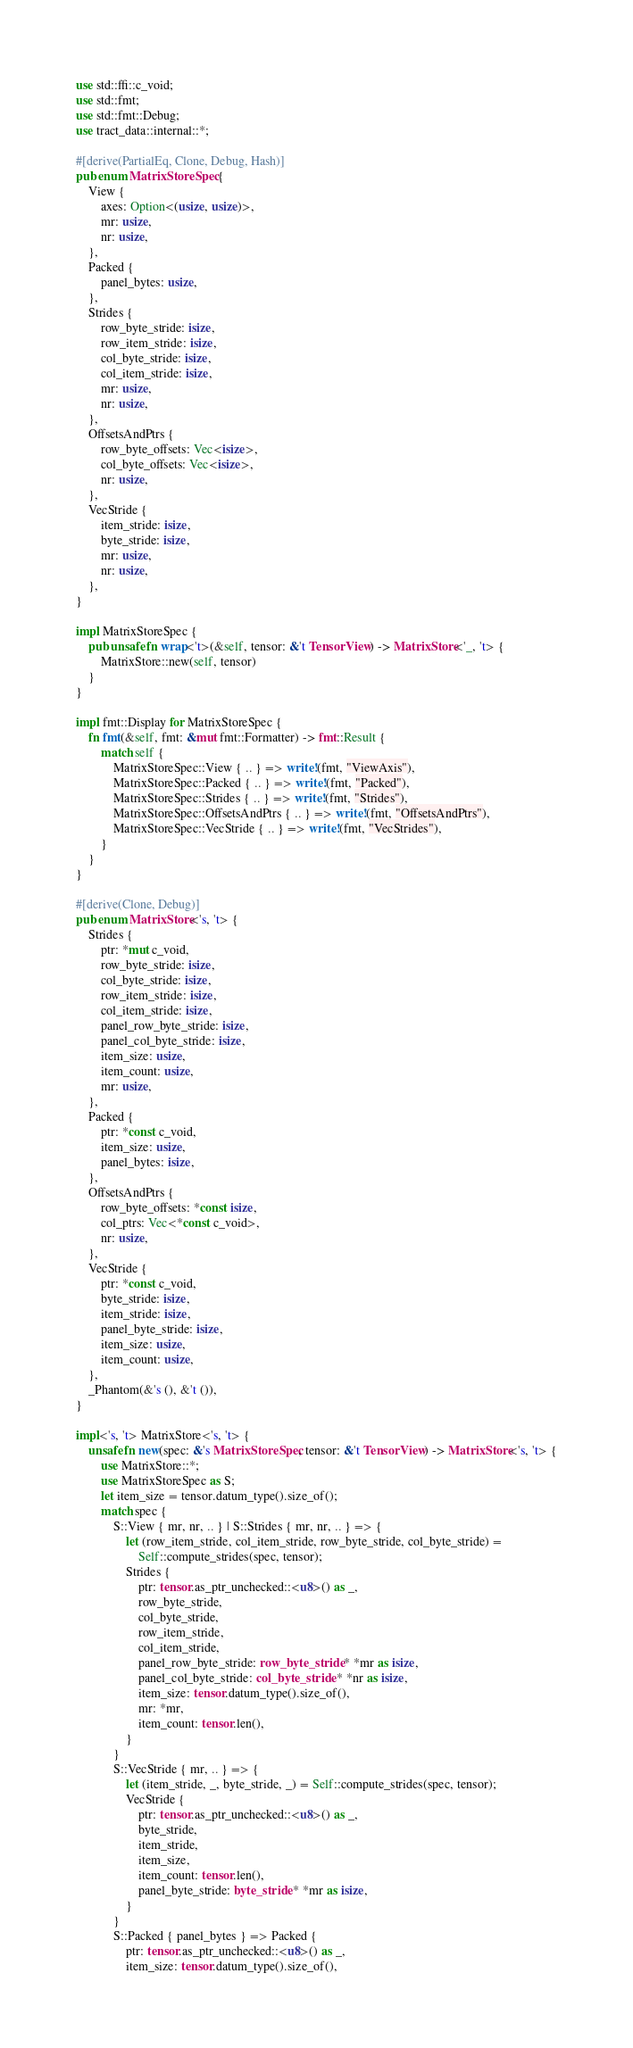<code> <loc_0><loc_0><loc_500><loc_500><_Rust_>use std::ffi::c_void;
use std::fmt;
use std::fmt::Debug;
use tract_data::internal::*;

#[derive(PartialEq, Clone, Debug, Hash)]
pub enum MatrixStoreSpec {
    View {
        axes: Option<(usize, usize)>,
        mr: usize,
        nr: usize,
    },
    Packed {
        panel_bytes: usize,
    },
    Strides {
        row_byte_stride: isize,
        row_item_stride: isize,
        col_byte_stride: isize,
        col_item_stride: isize,
        mr: usize,
        nr: usize,
    },
    OffsetsAndPtrs {
        row_byte_offsets: Vec<isize>,
        col_byte_offsets: Vec<isize>,
        nr: usize,
    },
    VecStride {
        item_stride: isize,
        byte_stride: isize,
        mr: usize,
        nr: usize,
    },
}

impl MatrixStoreSpec {
    pub unsafe fn wrap<'t>(&self, tensor: &'t TensorView) -> MatrixStore<'_, 't> {
        MatrixStore::new(self, tensor)
    }
}

impl fmt::Display for MatrixStoreSpec {
    fn fmt(&self, fmt: &mut fmt::Formatter) -> fmt::Result {
        match self {
            MatrixStoreSpec::View { .. } => write!(fmt, "ViewAxis"),
            MatrixStoreSpec::Packed { .. } => write!(fmt, "Packed"),
            MatrixStoreSpec::Strides { .. } => write!(fmt, "Strides"),
            MatrixStoreSpec::OffsetsAndPtrs { .. } => write!(fmt, "OffsetsAndPtrs"),
            MatrixStoreSpec::VecStride { .. } => write!(fmt, "VecStrides"),
        }
    }
}

#[derive(Clone, Debug)]
pub enum MatrixStore<'s, 't> {
    Strides {
        ptr: *mut c_void,
        row_byte_stride: isize,
        col_byte_stride: isize,
        row_item_stride: isize,
        col_item_stride: isize,
        panel_row_byte_stride: isize,
        panel_col_byte_stride: isize,
        item_size: usize,
        item_count: usize,
        mr: usize,
    },
    Packed {
        ptr: *const c_void,
        item_size: usize,
        panel_bytes: isize,
    },
    OffsetsAndPtrs {
        row_byte_offsets: *const isize,
        col_ptrs: Vec<*const c_void>,
        nr: usize,
    },
    VecStride {
        ptr: *const c_void,
        byte_stride: isize,
        item_stride: isize,
        panel_byte_stride: isize,
        item_size: usize,
        item_count: usize,
    },
    _Phantom(&'s (), &'t ()),
}

impl<'s, 't> MatrixStore<'s, 't> {
    unsafe fn new(spec: &'s MatrixStoreSpec, tensor: &'t TensorView) -> MatrixStore<'s, 't> {
        use MatrixStore::*;
        use MatrixStoreSpec as S;
        let item_size = tensor.datum_type().size_of();
        match spec {
            S::View { mr, nr, .. } | S::Strides { mr, nr, .. } => {
                let (row_item_stride, col_item_stride, row_byte_stride, col_byte_stride) =
                    Self::compute_strides(spec, tensor);
                Strides {
                    ptr: tensor.as_ptr_unchecked::<u8>() as _,
                    row_byte_stride,
                    col_byte_stride,
                    row_item_stride,
                    col_item_stride,
                    panel_row_byte_stride: row_byte_stride * *mr as isize,
                    panel_col_byte_stride: col_byte_stride * *nr as isize,
                    item_size: tensor.datum_type().size_of(),
                    mr: *mr,
                    item_count: tensor.len(),
                }
            }
            S::VecStride { mr, .. } => {
                let (item_stride, _, byte_stride, _) = Self::compute_strides(spec, tensor);
                VecStride {
                    ptr: tensor.as_ptr_unchecked::<u8>() as _,
                    byte_stride,
                    item_stride,
                    item_size,
                    item_count: tensor.len(),
                    panel_byte_stride: byte_stride * *mr as isize,
                }
            }
            S::Packed { panel_bytes } => Packed {
                ptr: tensor.as_ptr_unchecked::<u8>() as _,
                item_size: tensor.datum_type().size_of(),</code> 